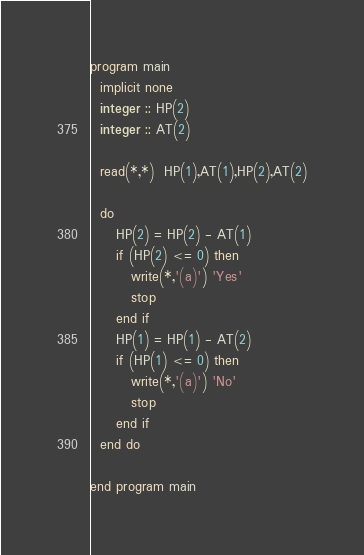Convert code to text. <code><loc_0><loc_0><loc_500><loc_500><_FORTRAN_>program main
  implicit none
  integer :: HP(2)
  integer :: AT(2)
  
  read(*,*)  HP(1),AT(1),HP(2),AT(2)

  do
     HP(2) = HP(2) - AT(1)
     if (HP(2) <= 0) then
        write(*,'(a)') 'Yes'
        stop
     end if
     HP(1) = HP(1) - AT(2)
     if (HP(1) <= 0) then
        write(*,'(a)') 'No'
        stop
     end if
  end do
  
end program main
</code> 